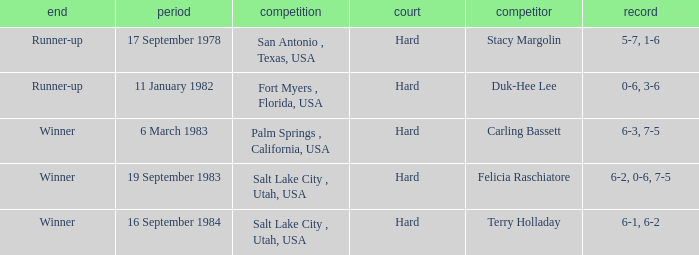Who was the opponent for the match were the outcome was runner-up and the score was 5-7, 1-6? Stacy Margolin. Would you mind parsing the complete table? {'header': ['end', 'period', 'competition', 'court', 'competitor', 'record'], 'rows': [['Runner-up', '17 September 1978', 'San Antonio , Texas, USA', 'Hard', 'Stacy Margolin', '5-7, 1-6'], ['Runner-up', '11 January 1982', 'Fort Myers , Florida, USA', 'Hard', 'Duk-Hee Lee', '0-6, 3-6'], ['Winner', '6 March 1983', 'Palm Springs , California, USA', 'Hard', 'Carling Bassett', '6-3, 7-5'], ['Winner', '19 September 1983', 'Salt Lake City , Utah, USA', 'Hard', 'Felicia Raschiatore', '6-2, 0-6, 7-5'], ['Winner', '16 September 1984', 'Salt Lake City , Utah, USA', 'Hard', 'Terry Holladay', '6-1, 6-2']]} 